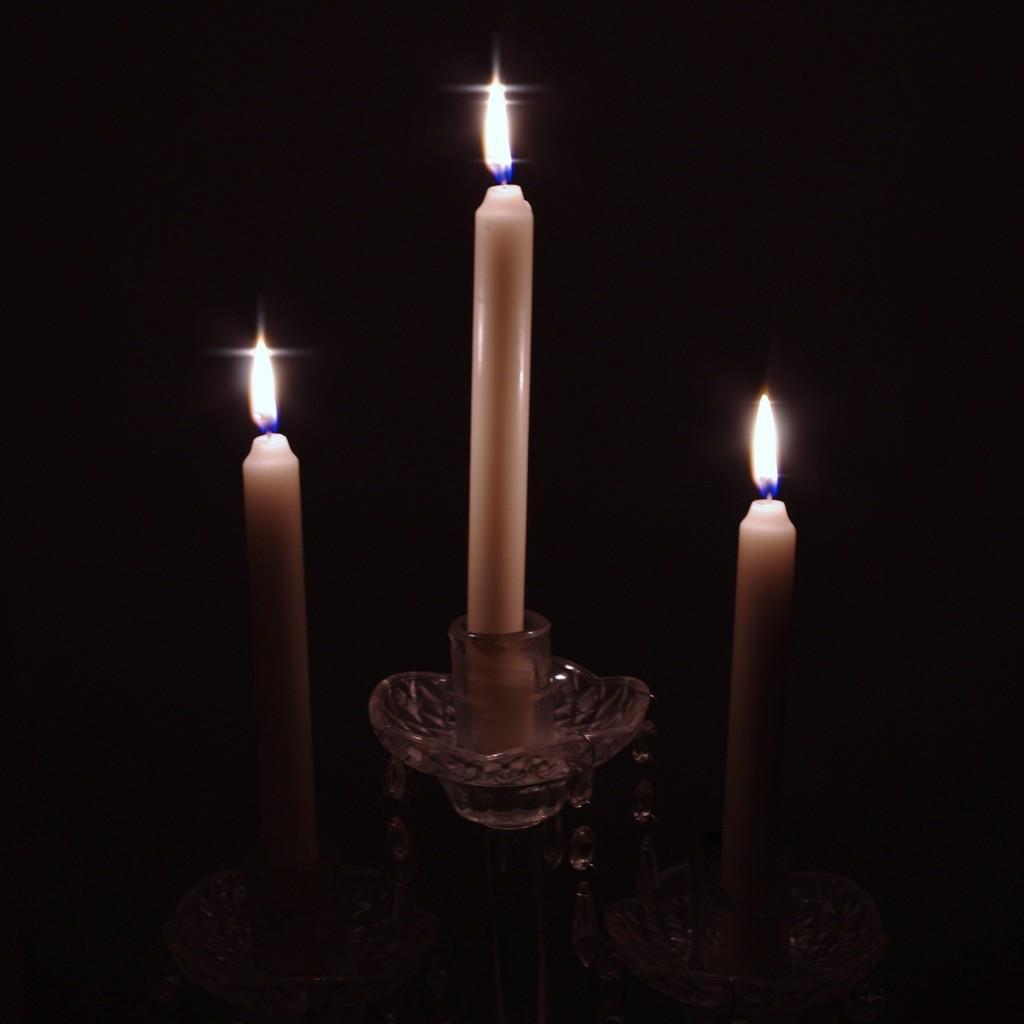Please provide a concise description of this image. In this picture I can see there are three candles arranged on the stand and the backdrop of the image is dark. 